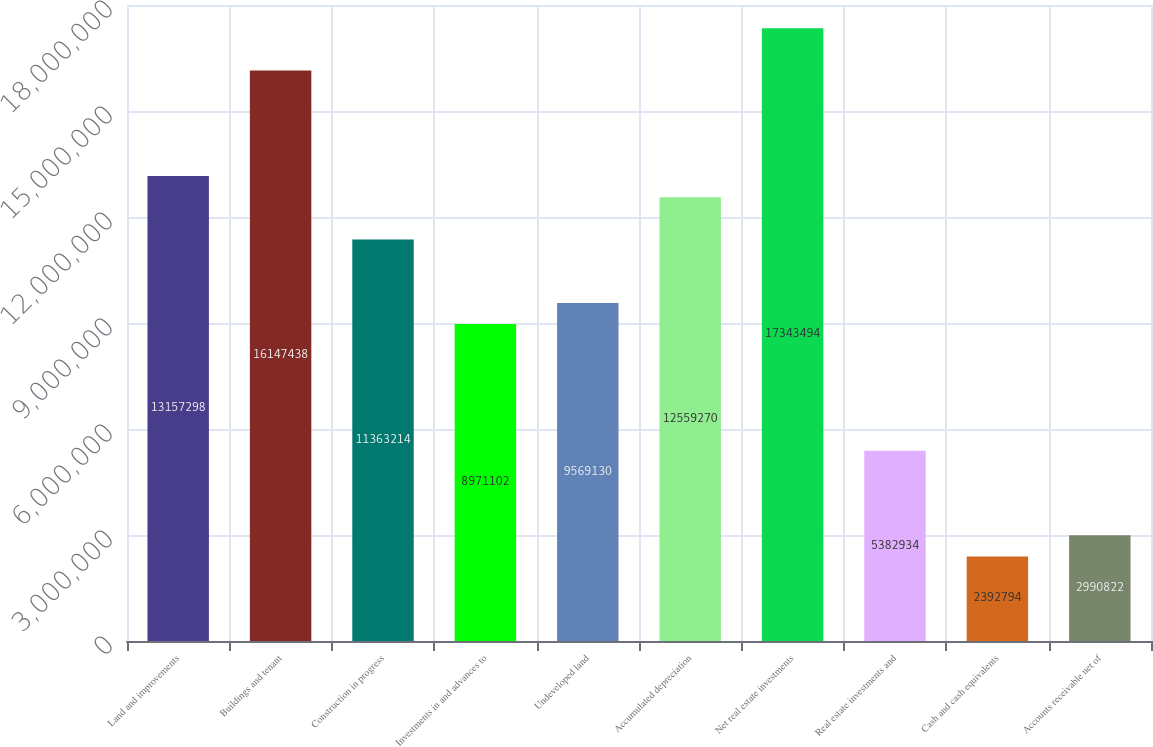<chart> <loc_0><loc_0><loc_500><loc_500><bar_chart><fcel>Land and improvements<fcel>Buildings and tenant<fcel>Construction in progress<fcel>Investments in and advances to<fcel>Undeveloped land<fcel>Accumulated depreciation<fcel>Net real estate investments<fcel>Real estate investments and<fcel>Cash and cash equivalents<fcel>Accounts receivable net of<nl><fcel>1.31573e+07<fcel>1.61474e+07<fcel>1.13632e+07<fcel>8.9711e+06<fcel>9.56913e+06<fcel>1.25593e+07<fcel>1.73435e+07<fcel>5.38293e+06<fcel>2.39279e+06<fcel>2.99082e+06<nl></chart> 